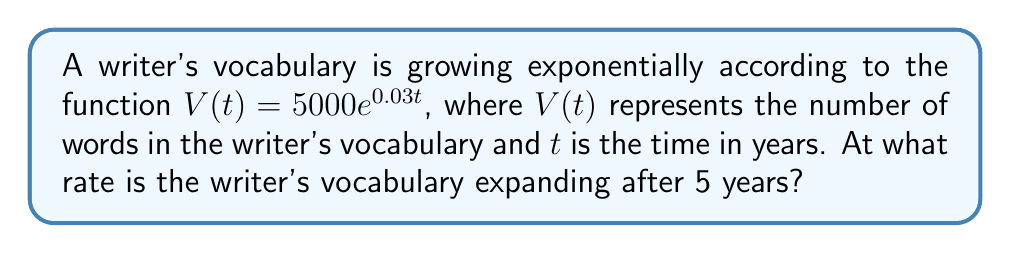Help me with this question. To determine the rate at which the writer's vocabulary is expanding after 5 years, we need to find the derivative of the given function and evaluate it at $t = 5$.

Step 1: Find the derivative of $V(t)$.
The derivative of $V(t) = 5000e^{0.03t}$ is:
$$V'(t) = 5000 \cdot 0.03 \cdot e^{0.03t} = 150e^{0.03t}$$

Step 2: Evaluate the derivative at $t = 5$.
$$V'(5) = 150e^{0.03 \cdot 5} = 150e^{0.15}$$

Step 3: Calculate the final value.
$$V'(5) = 150 \cdot 1.1618 \approx 174.27$$

The rate of vocabulary expansion is approximately 174.27 words per year after 5 years.
Answer: $174.27$ words per year 